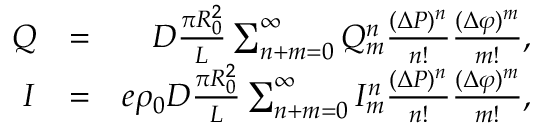<formula> <loc_0><loc_0><loc_500><loc_500>\begin{array} { r l r } { Q } & { = } & { D \frac { \pi R _ { 0 } ^ { 2 } } { L } \sum _ { n + m = 0 } ^ { \infty } Q _ { m } ^ { n } \frac { ( \Delta P ) ^ { n } } { n ! } \frac { ( \Delta \varphi ) ^ { m } } { m ! } , } \\ { I } & { = } & { e \rho _ { 0 } D \frac { \pi R _ { 0 } ^ { 2 } } { L } \sum _ { n + m = 0 } ^ { \infty } I _ { m } ^ { n } \frac { ( \Delta P ) ^ { n } } { n ! } \frac { ( \Delta \varphi ) ^ { m } } { m ! } , } \end{array}</formula> 